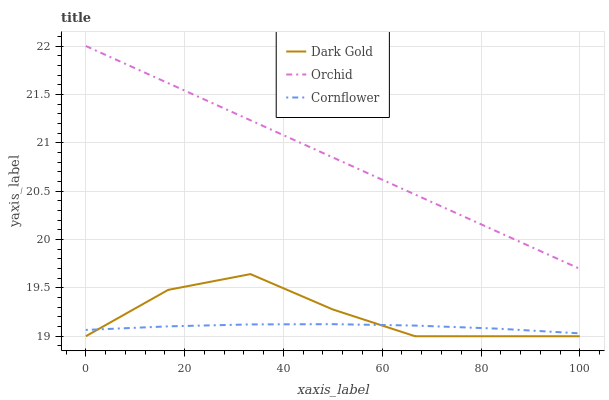Does Cornflower have the minimum area under the curve?
Answer yes or no. Yes. Does Orchid have the maximum area under the curve?
Answer yes or no. Yes. Does Dark Gold have the minimum area under the curve?
Answer yes or no. No. Does Dark Gold have the maximum area under the curve?
Answer yes or no. No. Is Orchid the smoothest?
Answer yes or no. Yes. Is Dark Gold the roughest?
Answer yes or no. Yes. Is Dark Gold the smoothest?
Answer yes or no. No. Is Orchid the roughest?
Answer yes or no. No. Does Orchid have the lowest value?
Answer yes or no. No. Does Dark Gold have the highest value?
Answer yes or no. No. Is Dark Gold less than Orchid?
Answer yes or no. Yes. Is Orchid greater than Dark Gold?
Answer yes or no. Yes. Does Dark Gold intersect Orchid?
Answer yes or no. No. 